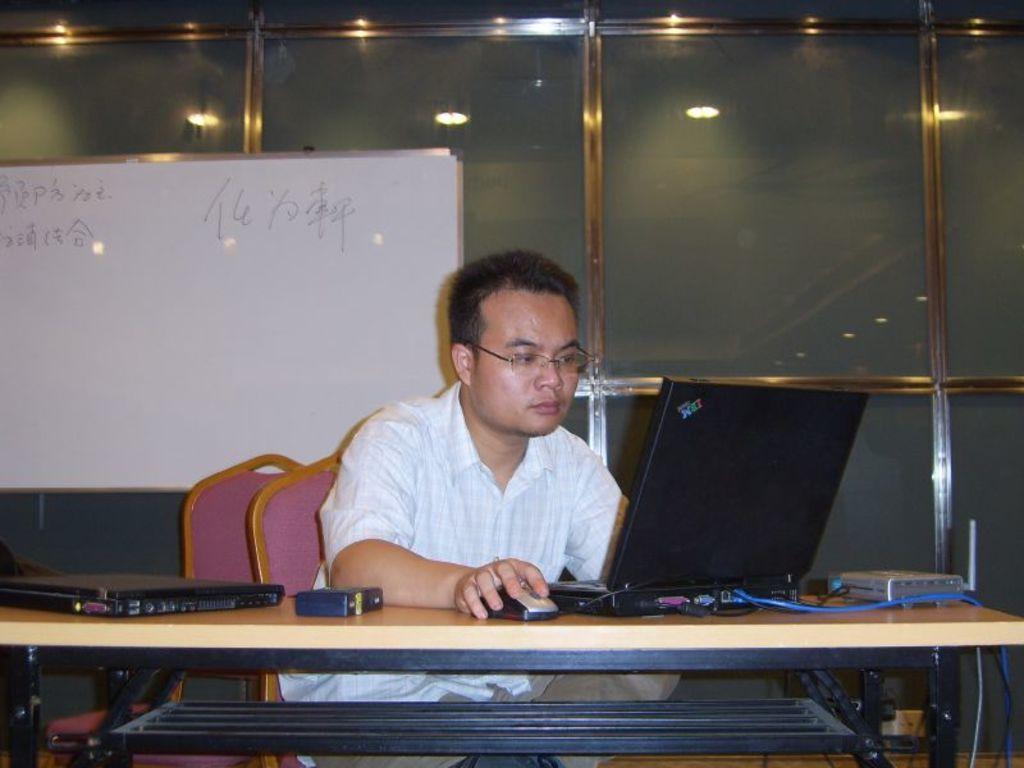Can you describe this image briefly? Here we can see a man who is sitting on the chair. He has spectacles. This is table. On the table there are laptops, and a mouse. On the background there is a glass. This is board and these are the lights. 